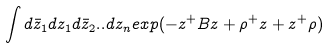Convert formula to latex. <formula><loc_0><loc_0><loc_500><loc_500>\int d { \bar { z } } _ { 1 } d z _ { 1 } d { \bar { z } } _ { 2 } . . d z _ { n } e x p ( - z ^ { + } B z + \rho ^ { + } z + z ^ { + } \rho )</formula> 